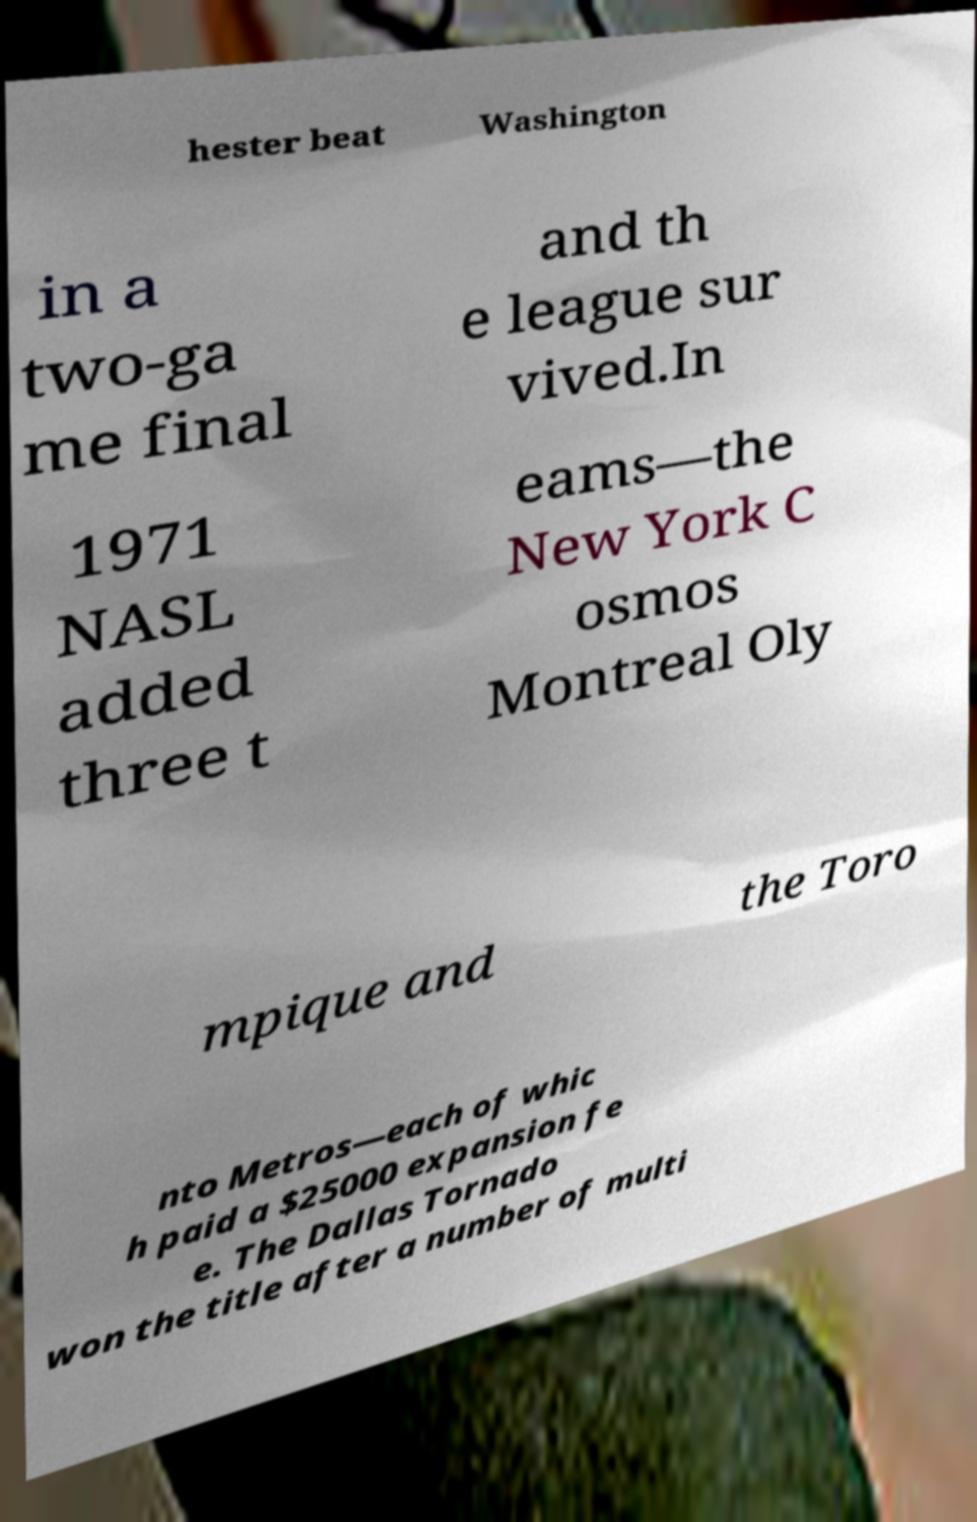Could you assist in decoding the text presented in this image and type it out clearly? hester beat Washington in a two-ga me final and th e league sur vived.In 1971 NASL added three t eams—the New York C osmos Montreal Oly mpique and the Toro nto Metros—each of whic h paid a $25000 expansion fe e. The Dallas Tornado won the title after a number of multi 